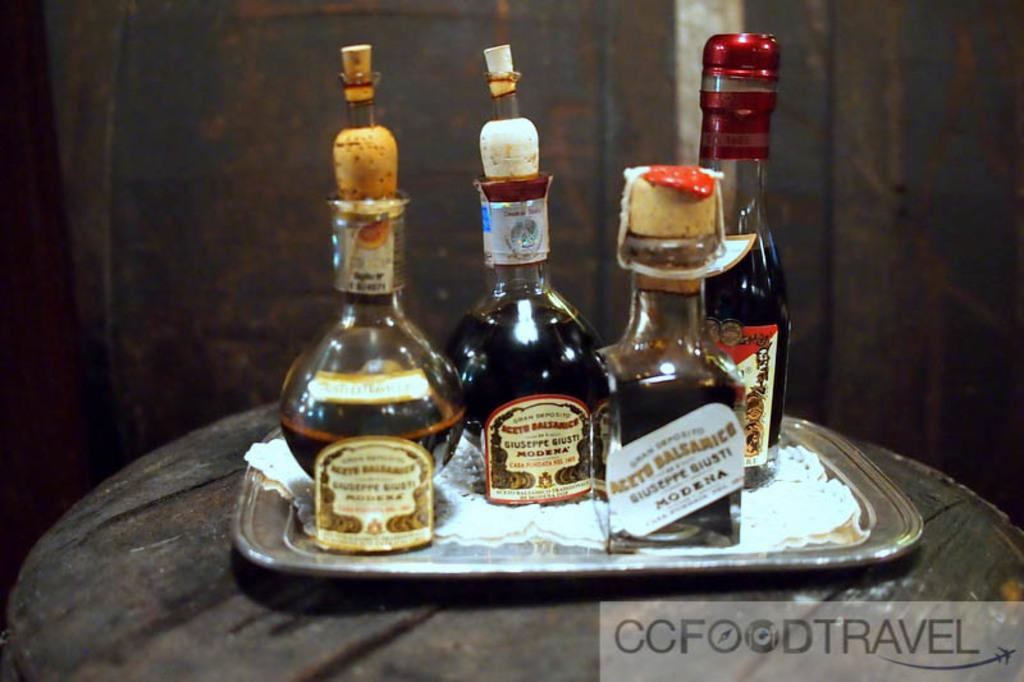<image>
Render a clear and concise summary of the photo. Four different Guiseppe Giusti Modena bottles are displayed on a silver tray. 